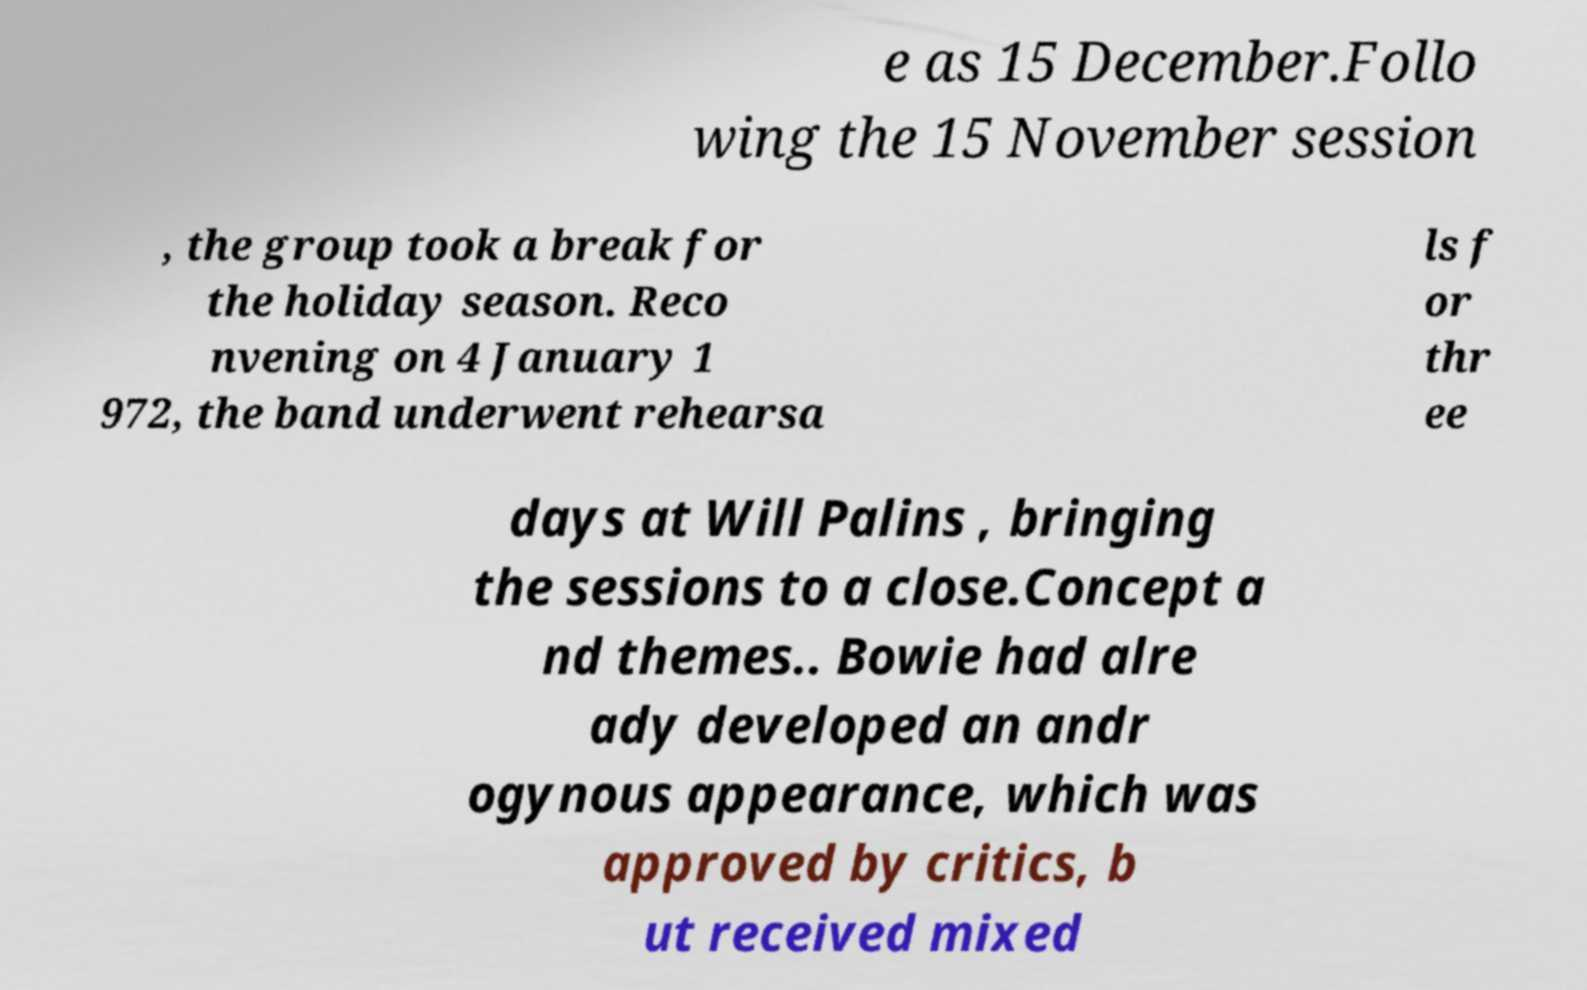Could you assist in decoding the text presented in this image and type it out clearly? e as 15 December.Follo wing the 15 November session , the group took a break for the holiday season. Reco nvening on 4 January 1 972, the band underwent rehearsa ls f or thr ee days at Will Palins , bringing the sessions to a close.Concept a nd themes.. Bowie had alre ady developed an andr ogynous appearance, which was approved by critics, b ut received mixed 